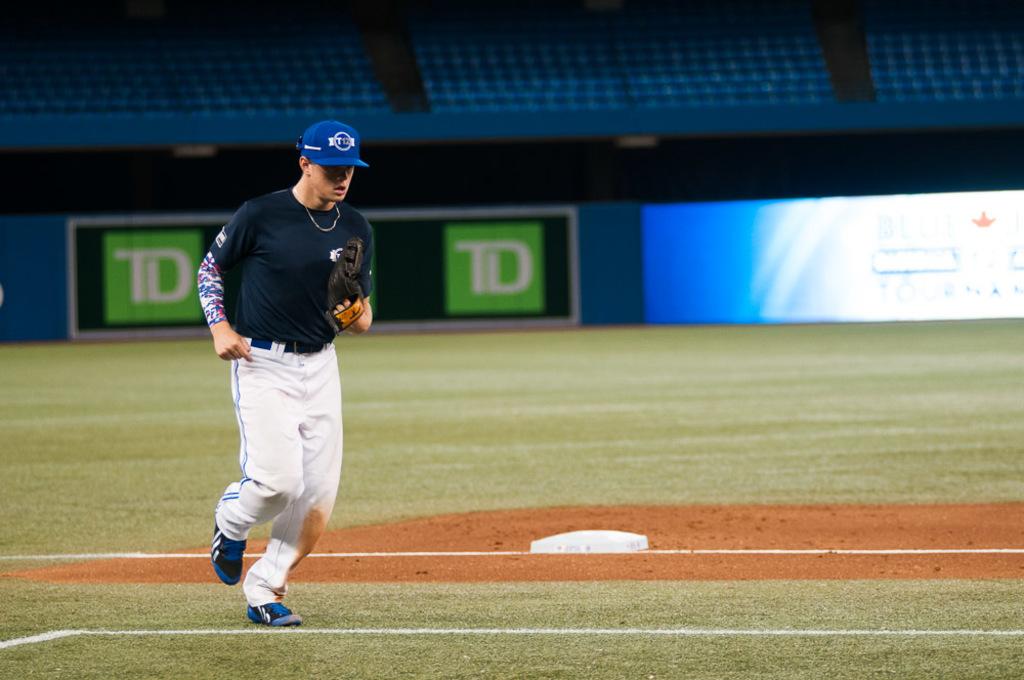Which two letters are on the green signs?
Your answer should be compact. Td. 